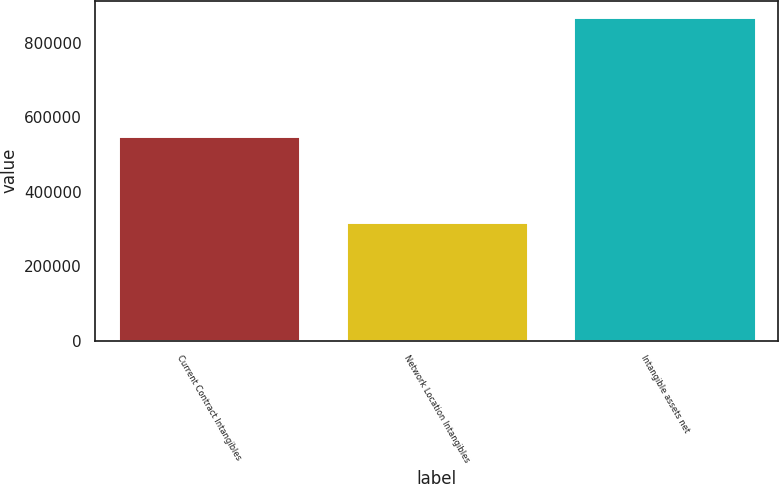Convert chart to OTSL. <chart><loc_0><loc_0><loc_500><loc_500><bar_chart><fcel>Current Contract Intangibles<fcel>Network Location Intangibles<fcel>Intangible assets net<nl><fcel>549583<fcel>319416<fcel>868999<nl></chart> 